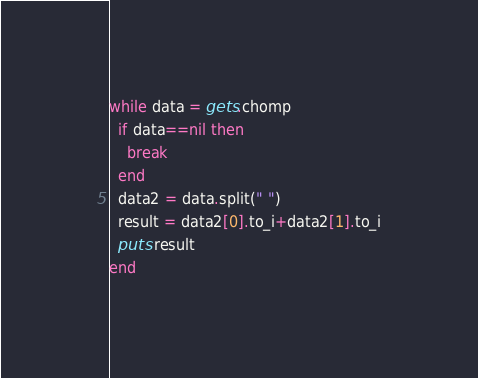<code> <loc_0><loc_0><loc_500><loc_500><_Ruby_>while data = gets.chomp
  if data==nil then
    break
  end
  data2 = data.split(" ")
  result = data2[0].to_i+data2[1].to_i
  puts result
end</code> 